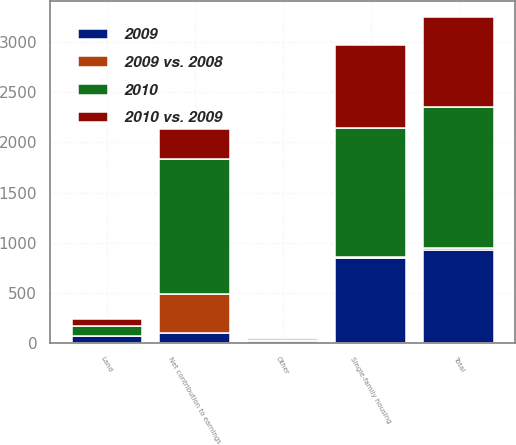<chart> <loc_0><loc_0><loc_500><loc_500><stacked_bar_chart><ecel><fcel>Single-family housing<fcel>Land<fcel>Other<fcel>Total<fcel>Net contribution to earnings<nl><fcel>2009<fcel>842<fcel>64<fcel>17<fcel>923<fcel>91<nl><fcel>2010 vs. 2009<fcel>832<fcel>68<fcel>4<fcel>904<fcel>299<nl><fcel>2010<fcel>1294<fcel>99<fcel>15<fcel>1408<fcel>1357<nl><fcel>2009 vs. 2008<fcel>10<fcel>4<fcel>13<fcel>19<fcel>390<nl></chart> 